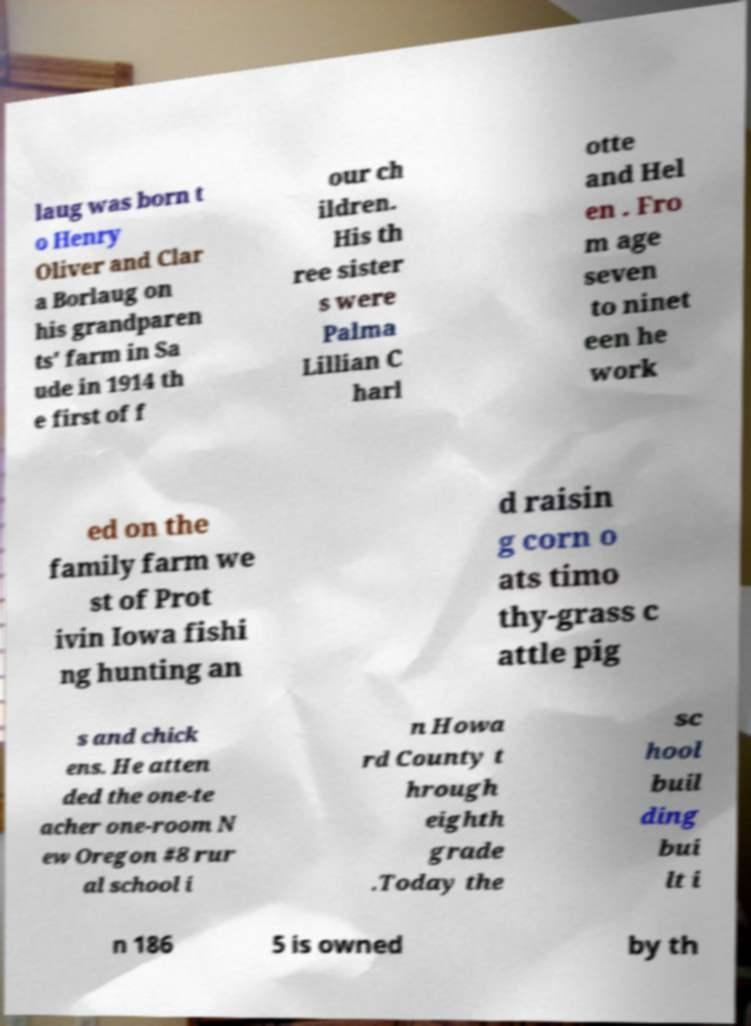Could you assist in decoding the text presented in this image and type it out clearly? laug was born t o Henry Oliver and Clar a Borlaug on his grandparen ts' farm in Sa ude in 1914 th e first of f our ch ildren. His th ree sister s were Palma Lillian C harl otte and Hel en . Fro m age seven to ninet een he work ed on the family farm we st of Prot ivin Iowa fishi ng hunting an d raisin g corn o ats timo thy-grass c attle pig s and chick ens. He atten ded the one-te acher one-room N ew Oregon #8 rur al school i n Howa rd County t hrough eighth grade .Today the sc hool buil ding bui lt i n 186 5 is owned by th 